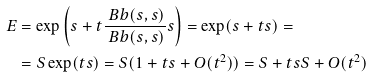<formula> <loc_0><loc_0><loc_500><loc_500>E & = \exp \left ( s + t \frac { \ B b ( s , s ) } { \ B b ( s , s ) } s \right ) = \exp ( s + t s ) = \\ & = S \exp ( t s ) = S ( 1 + t s + O ( t ^ { 2 } ) ) = S + t s S + O ( t ^ { 2 } )</formula> 